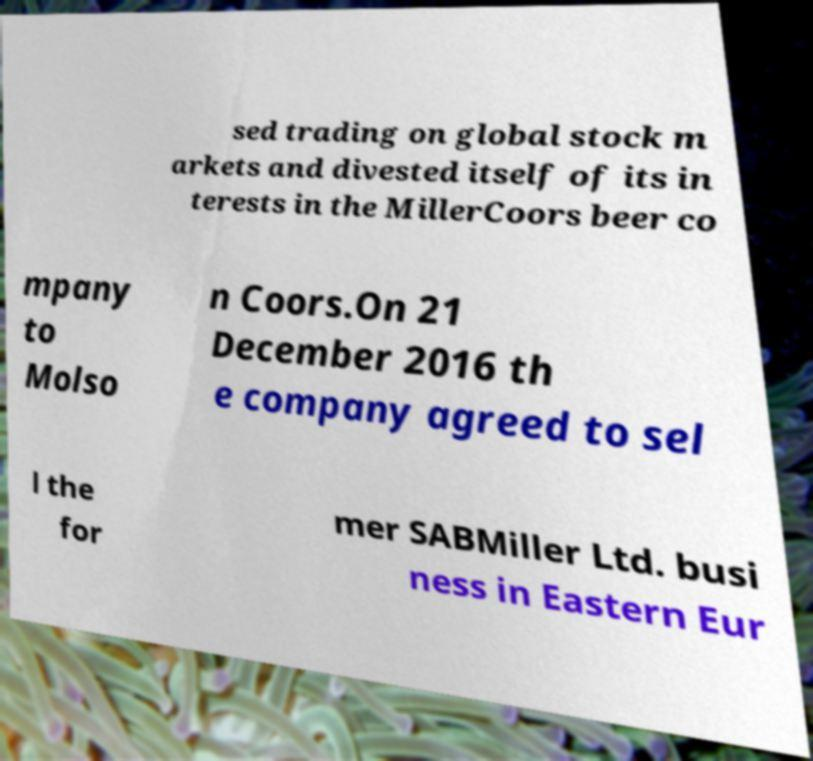Could you extract and type out the text from this image? sed trading on global stock m arkets and divested itself of its in terests in the MillerCoors beer co mpany to Molso n Coors.On 21 December 2016 th e company agreed to sel l the for mer SABMiller Ltd. busi ness in Eastern Eur 